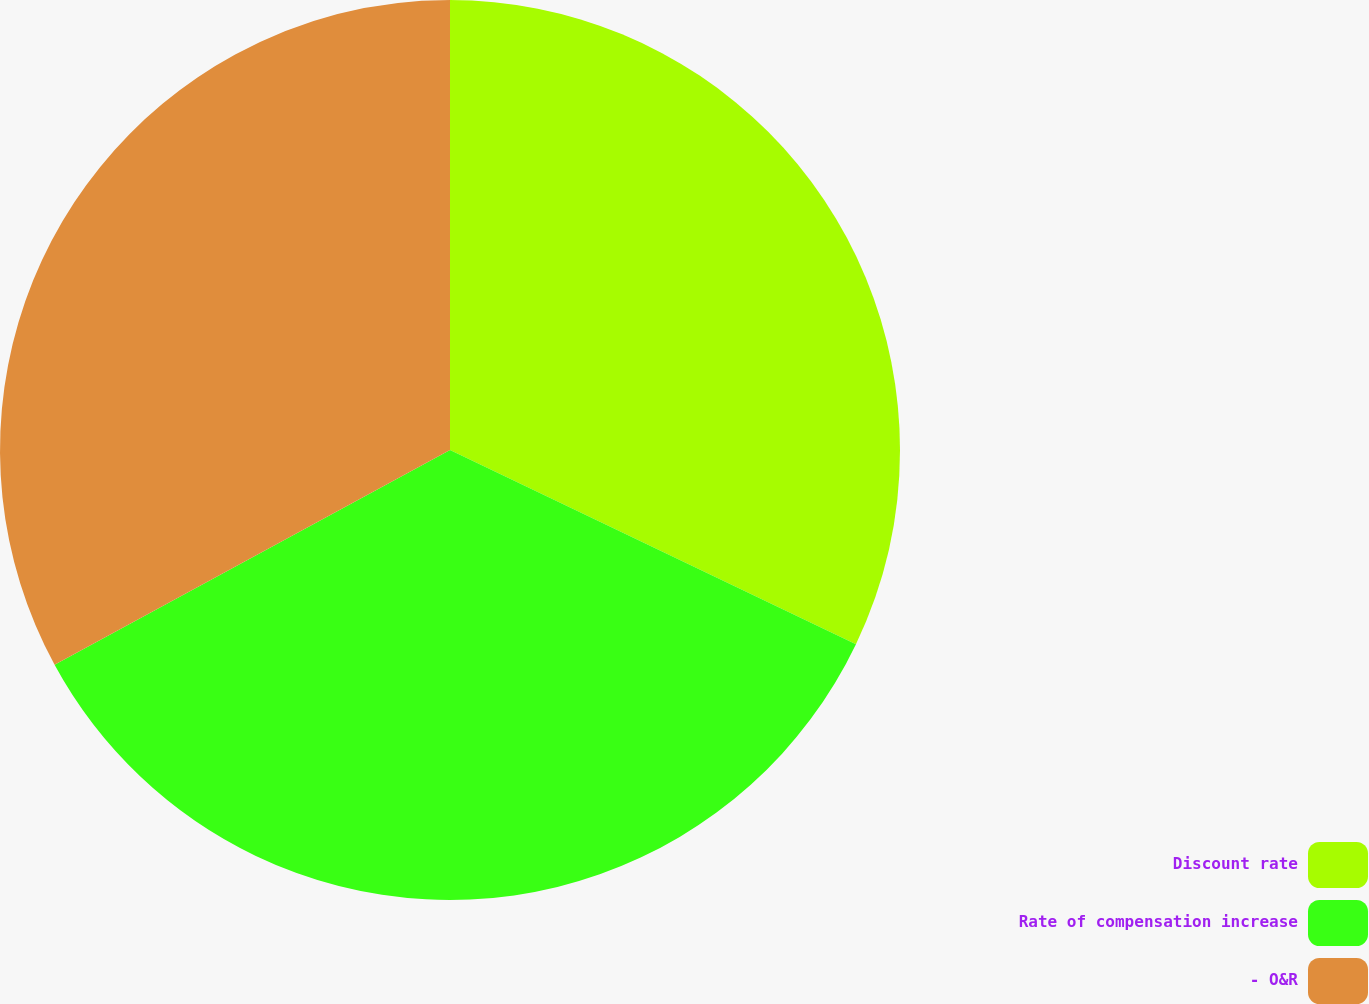Convert chart. <chart><loc_0><loc_0><loc_500><loc_500><pie_chart><fcel>Discount rate<fcel>Rate of compensation increase<fcel>- O&R<nl><fcel>32.1%<fcel>34.98%<fcel>32.92%<nl></chart> 